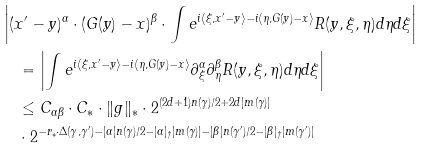Convert formula to latex. <formula><loc_0><loc_0><loc_500><loc_500>& \left | ( x ^ { \prime } - y ) ^ { \alpha } \cdot ( G ( y ) - x ) ^ { \beta } \cdot \int e ^ { i \langle \xi , x ^ { \prime } - y \rangle - i \langle \eta , G ( y ) - x \rangle } R ( y , \xi , \eta ) d \eta d \xi \right | \\ & \quad = \left | \int e ^ { i \langle \xi , x ^ { \prime } - y \rangle - i \langle \eta , G ( y ) - x \rangle } \partial ^ { \alpha } _ { \xi } \partial ^ { \beta } _ { \eta } R ( y , \xi , \eta ) d \eta d \xi \right | \\ & \quad \leq C _ { \alpha \beta } \cdot C _ { * } \cdot \| g \| _ { * } \cdot 2 ^ { ( 2 d + 1 ) n ( \gamma ) / 2 + 2 d | m ( \gamma ) | } \\ & \quad \cdot 2 ^ { - r _ { * } \cdot \Delta ( \gamma , \gamma ^ { \prime } ) - | \alpha | n ( \gamma ) / 2 - | \alpha | _ { \dag } | m ( \gamma ) | - | \beta | n ( \gamma ^ { \prime } ) / 2 - | \beta | _ { \dag } | m ( \gamma ^ { \prime } ) | }</formula> 